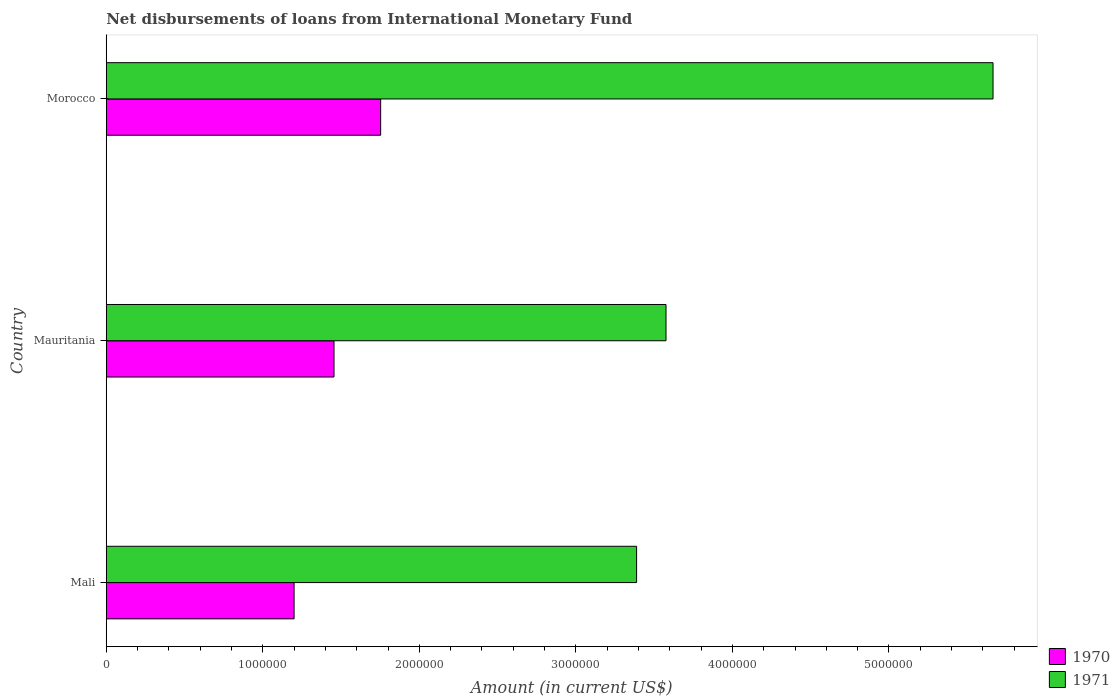How many groups of bars are there?
Offer a very short reply. 3. Are the number of bars per tick equal to the number of legend labels?
Provide a succinct answer. Yes. Are the number of bars on each tick of the Y-axis equal?
Your response must be concise. Yes. How many bars are there on the 2nd tick from the bottom?
Your answer should be compact. 2. What is the label of the 3rd group of bars from the top?
Ensure brevity in your answer.  Mali. What is the amount of loans disbursed in 1971 in Mauritania?
Provide a succinct answer. 3.58e+06. Across all countries, what is the maximum amount of loans disbursed in 1970?
Give a very brief answer. 1.75e+06. Across all countries, what is the minimum amount of loans disbursed in 1971?
Your response must be concise. 3.39e+06. In which country was the amount of loans disbursed in 1970 maximum?
Provide a succinct answer. Morocco. In which country was the amount of loans disbursed in 1971 minimum?
Your answer should be compact. Mali. What is the total amount of loans disbursed in 1971 in the graph?
Provide a succinct answer. 1.26e+07. What is the difference between the amount of loans disbursed in 1970 in Mauritania and that in Morocco?
Your answer should be very brief. -2.98e+05. What is the difference between the amount of loans disbursed in 1971 in Morocco and the amount of loans disbursed in 1970 in Mali?
Provide a succinct answer. 4.46e+06. What is the average amount of loans disbursed in 1971 per country?
Keep it short and to the point. 4.21e+06. What is the difference between the amount of loans disbursed in 1970 and amount of loans disbursed in 1971 in Mauritania?
Your answer should be compact. -2.12e+06. What is the ratio of the amount of loans disbursed in 1970 in Mali to that in Mauritania?
Provide a short and direct response. 0.82. Is the amount of loans disbursed in 1970 in Mali less than that in Mauritania?
Offer a terse response. Yes. Is the difference between the amount of loans disbursed in 1970 in Mauritania and Morocco greater than the difference between the amount of loans disbursed in 1971 in Mauritania and Morocco?
Your response must be concise. Yes. What is the difference between the highest and the second highest amount of loans disbursed in 1970?
Your answer should be very brief. 2.98e+05. What is the difference between the highest and the lowest amount of loans disbursed in 1970?
Give a very brief answer. 5.53e+05. In how many countries, is the amount of loans disbursed in 1970 greater than the average amount of loans disbursed in 1970 taken over all countries?
Make the answer very short. 1. What does the 1st bar from the top in Morocco represents?
Your answer should be compact. 1971. How many countries are there in the graph?
Offer a terse response. 3. Are the values on the major ticks of X-axis written in scientific E-notation?
Your answer should be compact. No. Where does the legend appear in the graph?
Your answer should be very brief. Bottom right. How are the legend labels stacked?
Your answer should be compact. Vertical. What is the title of the graph?
Your answer should be very brief. Net disbursements of loans from International Monetary Fund. What is the label or title of the X-axis?
Make the answer very short. Amount (in current US$). What is the label or title of the Y-axis?
Your response must be concise. Country. What is the Amount (in current US$) in 1970 in Mali?
Your response must be concise. 1.20e+06. What is the Amount (in current US$) of 1971 in Mali?
Keep it short and to the point. 3.39e+06. What is the Amount (in current US$) of 1970 in Mauritania?
Offer a very short reply. 1.46e+06. What is the Amount (in current US$) in 1971 in Mauritania?
Offer a very short reply. 3.58e+06. What is the Amount (in current US$) of 1970 in Morocco?
Provide a short and direct response. 1.75e+06. What is the Amount (in current US$) of 1971 in Morocco?
Your response must be concise. 5.66e+06. Across all countries, what is the maximum Amount (in current US$) in 1970?
Your answer should be compact. 1.75e+06. Across all countries, what is the maximum Amount (in current US$) of 1971?
Offer a terse response. 5.66e+06. Across all countries, what is the minimum Amount (in current US$) in 1970?
Your answer should be very brief. 1.20e+06. Across all countries, what is the minimum Amount (in current US$) of 1971?
Your response must be concise. 3.39e+06. What is the total Amount (in current US$) in 1970 in the graph?
Make the answer very short. 4.41e+06. What is the total Amount (in current US$) in 1971 in the graph?
Keep it short and to the point. 1.26e+07. What is the difference between the Amount (in current US$) of 1970 in Mali and that in Mauritania?
Keep it short and to the point. -2.55e+05. What is the difference between the Amount (in current US$) in 1971 in Mali and that in Mauritania?
Offer a terse response. -1.88e+05. What is the difference between the Amount (in current US$) in 1970 in Mali and that in Morocco?
Make the answer very short. -5.53e+05. What is the difference between the Amount (in current US$) in 1971 in Mali and that in Morocco?
Your response must be concise. -2.28e+06. What is the difference between the Amount (in current US$) of 1970 in Mauritania and that in Morocco?
Your response must be concise. -2.98e+05. What is the difference between the Amount (in current US$) in 1971 in Mauritania and that in Morocco?
Offer a very short reply. -2.09e+06. What is the difference between the Amount (in current US$) of 1970 in Mali and the Amount (in current US$) of 1971 in Mauritania?
Your answer should be compact. -2.38e+06. What is the difference between the Amount (in current US$) of 1970 in Mali and the Amount (in current US$) of 1971 in Morocco?
Provide a short and direct response. -4.46e+06. What is the difference between the Amount (in current US$) in 1970 in Mauritania and the Amount (in current US$) in 1971 in Morocco?
Give a very brief answer. -4.21e+06. What is the average Amount (in current US$) in 1970 per country?
Keep it short and to the point. 1.47e+06. What is the average Amount (in current US$) in 1971 per country?
Your answer should be very brief. 4.21e+06. What is the difference between the Amount (in current US$) in 1970 and Amount (in current US$) in 1971 in Mali?
Provide a succinct answer. -2.19e+06. What is the difference between the Amount (in current US$) in 1970 and Amount (in current US$) in 1971 in Mauritania?
Your response must be concise. -2.12e+06. What is the difference between the Amount (in current US$) of 1970 and Amount (in current US$) of 1971 in Morocco?
Keep it short and to the point. -3.91e+06. What is the ratio of the Amount (in current US$) in 1970 in Mali to that in Mauritania?
Provide a succinct answer. 0.82. What is the ratio of the Amount (in current US$) of 1971 in Mali to that in Mauritania?
Keep it short and to the point. 0.95. What is the ratio of the Amount (in current US$) of 1970 in Mali to that in Morocco?
Give a very brief answer. 0.68. What is the ratio of the Amount (in current US$) in 1971 in Mali to that in Morocco?
Keep it short and to the point. 0.6. What is the ratio of the Amount (in current US$) of 1970 in Mauritania to that in Morocco?
Offer a very short reply. 0.83. What is the ratio of the Amount (in current US$) of 1971 in Mauritania to that in Morocco?
Offer a terse response. 0.63. What is the difference between the highest and the second highest Amount (in current US$) of 1970?
Offer a terse response. 2.98e+05. What is the difference between the highest and the second highest Amount (in current US$) in 1971?
Your response must be concise. 2.09e+06. What is the difference between the highest and the lowest Amount (in current US$) in 1970?
Your response must be concise. 5.53e+05. What is the difference between the highest and the lowest Amount (in current US$) of 1971?
Give a very brief answer. 2.28e+06. 